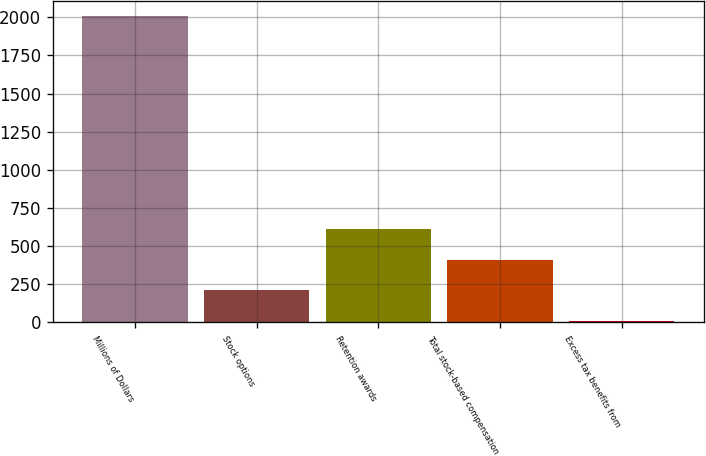<chart> <loc_0><loc_0><loc_500><loc_500><bar_chart><fcel>Millions of Dollars<fcel>Stock options<fcel>Retention awards<fcel>Total stock-based compensation<fcel>Excess tax benefits from<nl><fcel>2009<fcel>209.9<fcel>609.7<fcel>409.8<fcel>10<nl></chart> 